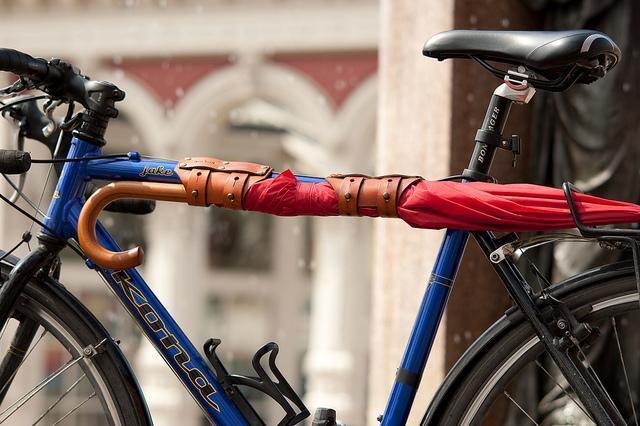Is the caption "The umbrella is attached to the bicycle." a true representation of the image?
Answer yes or no. Yes. 